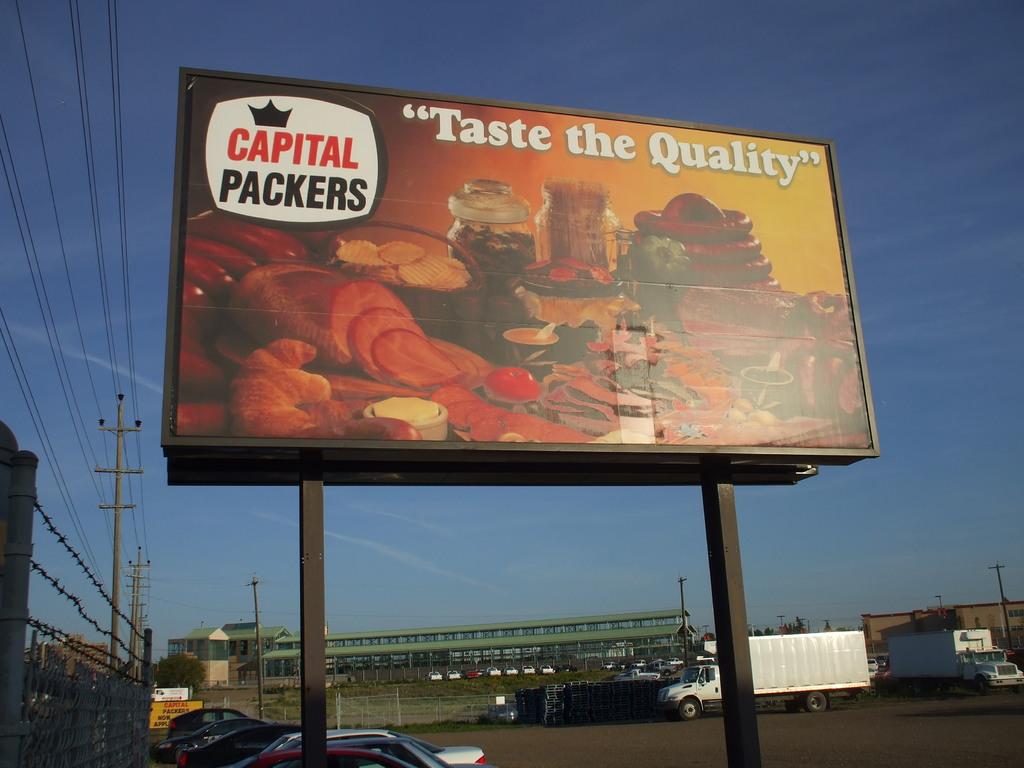What words are in quotation marks on the billboard?
Provide a succinct answer. Taste the quality. 